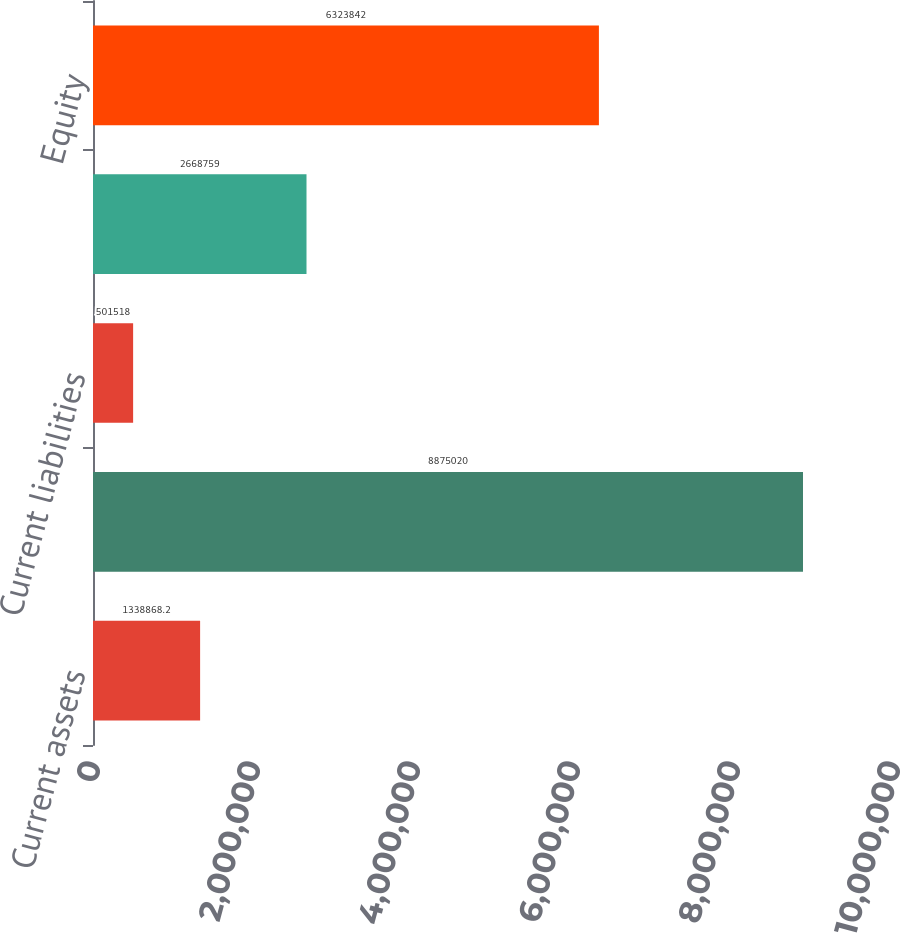Convert chart to OTSL. <chart><loc_0><loc_0><loc_500><loc_500><bar_chart><fcel>Current assets<fcel>Property and other long-term<fcel>Current liabilities<fcel>Long-term debt and other<fcel>Equity<nl><fcel>1.33887e+06<fcel>8.87502e+06<fcel>501518<fcel>2.66876e+06<fcel>6.32384e+06<nl></chart> 